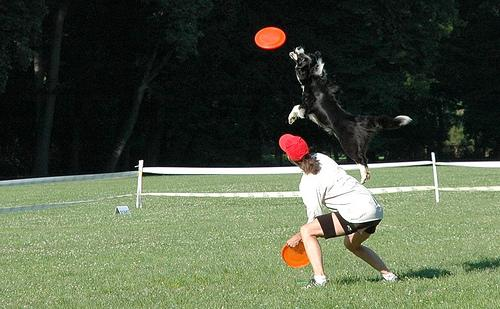What is the dog ready to do? Please explain your reasoning. catch. The dog is ready to catch the frisbee. 